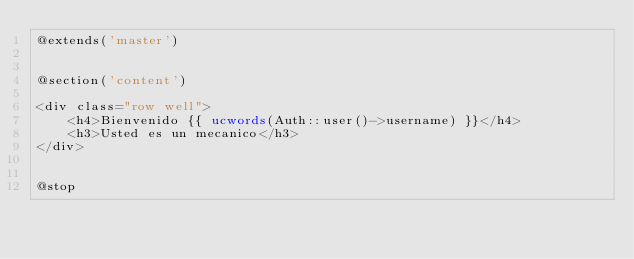Convert code to text. <code><loc_0><loc_0><loc_500><loc_500><_PHP_>@extends('master')


@section('content')

<div class="row well">
	<h4>Bienvenido {{ ucwords(Auth::user()->username) }}</h4>
	<h3>Usted es un mecanico</h3>
</div>


@stop</code> 